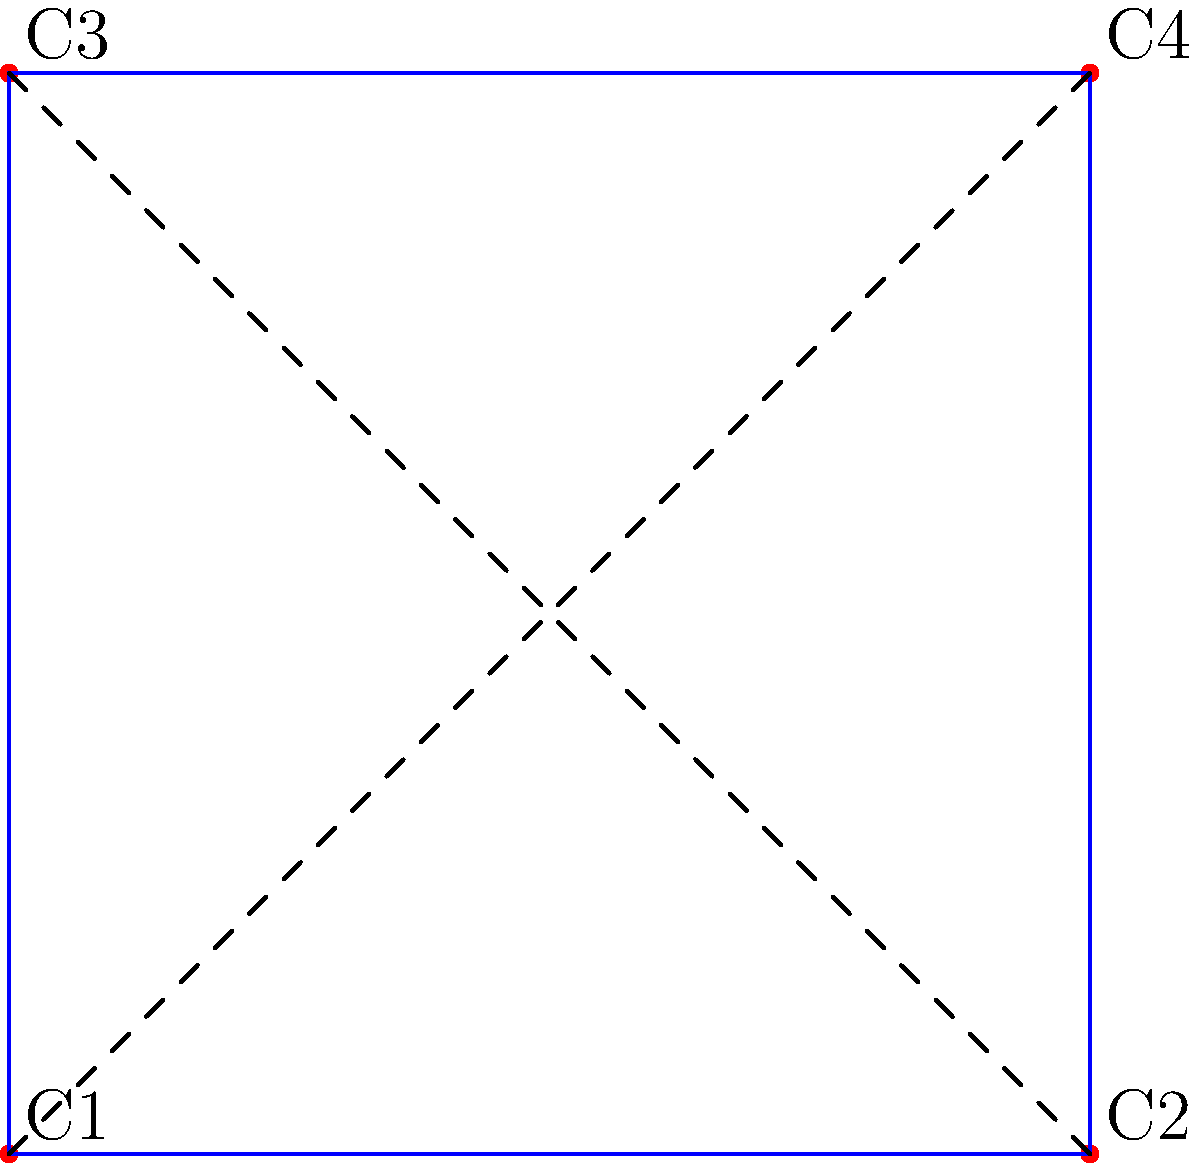As an app developer focused on user experience, you're designing a circuit layout tool. Given the circuit diagram above with four components (C1, C2, C3, C4) and their connections, what is the minimum number of crossing connections possible by rearranging the components? To solve this problem, we need to analyze the connections and find the optimal arrangement:

1. First, identify all connections:
   - C1 to C2, C1 to C3, C1 to C4
   - C2 to C4
   - C3 to C4

2. Observe that C1 and C4 are connected to all other components, while C2 and C3 are only connected to C1 and C4.

3. The optimal arrangement would be to place C1 and C4 at opposite corners, with C2 and C3 at the other two corners.

4. This arrangement allows for:
   - C1 to C2 and C1 to C3 connections without crossing
   - C4 to C2 and C4 to C3 connections without crossing
   - Only the C1 to C4 connection would need to cross the diagram

5. Therefore, the minimum number of crossing connections is 1.

This solution optimizes the layout for user experience by minimizing visual clutter and complexity in the circuit diagram.
Answer: 1 